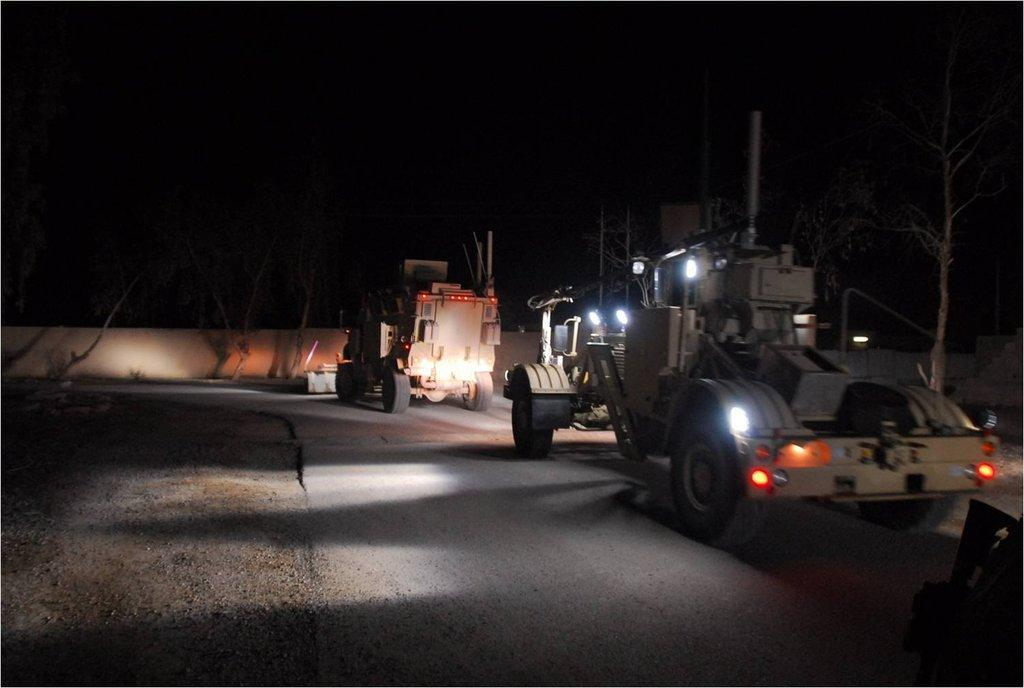What can be seen on the road in the image? There are vehicles on the road in the image. What type of natural elements are present in the image? There are trees in the image. What are the vertical structures in the image? There are poles in the image. What type of illumination is present in the image? There are lights in the image. What type of man-made structure is present in the image? There is a wall in the image. How would you describe the overall lighting in the image? The background of the image is dark. Where is the wrench being used in the image? There is no wrench present in the image. What type of structure is being built in the image? There is no structure being built in the image. Can you point out the map in the image? There is no map present in the image. 